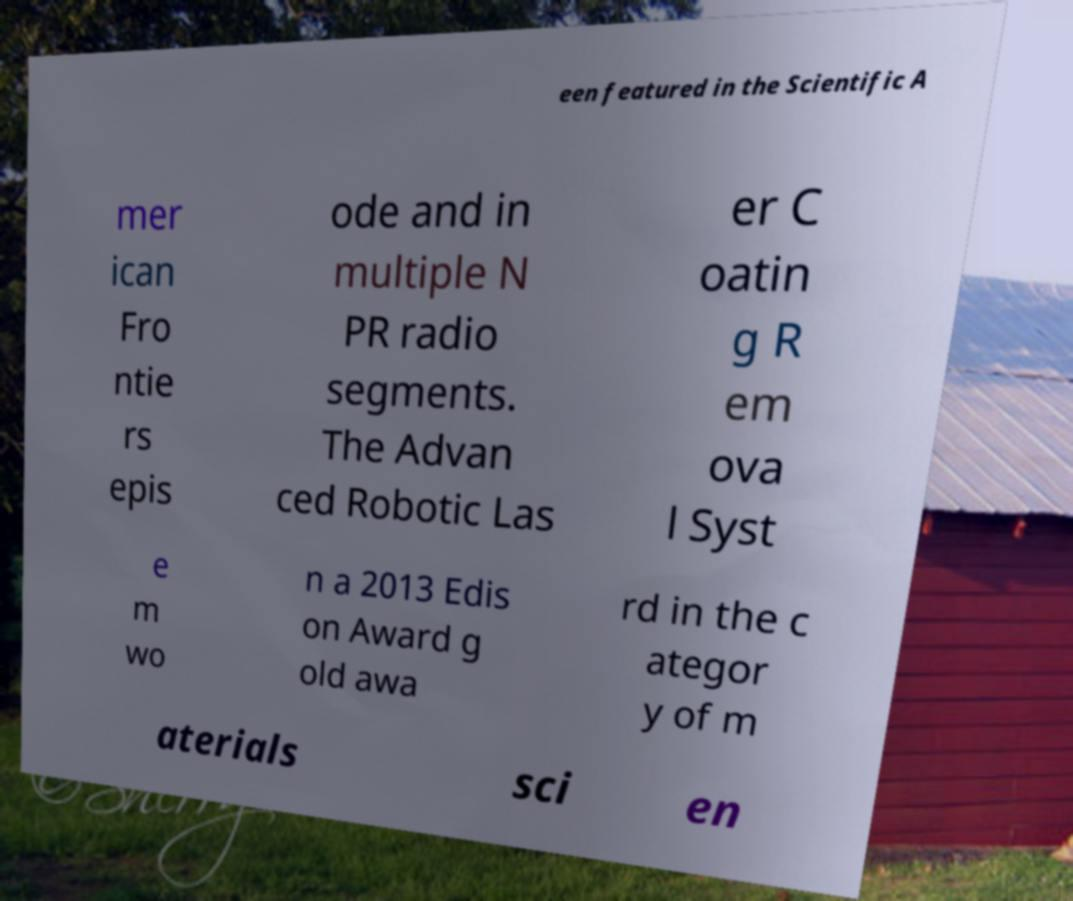Please identify and transcribe the text found in this image. een featured in the Scientific A mer ican Fro ntie rs epis ode and in multiple N PR radio segments. The Advan ced Robotic Las er C oatin g R em ova l Syst e m wo n a 2013 Edis on Award g old awa rd in the c ategor y of m aterials sci en 